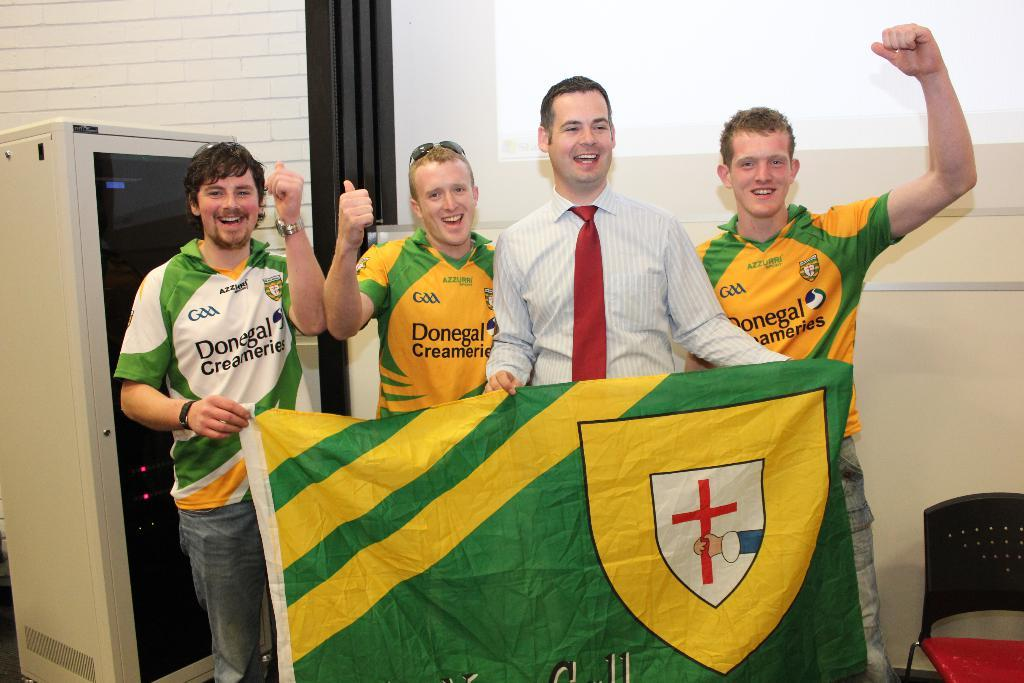Provide a one-sentence caption for the provided image. People for a sports team sponsored by Donegal Creameries pose with a flag. 